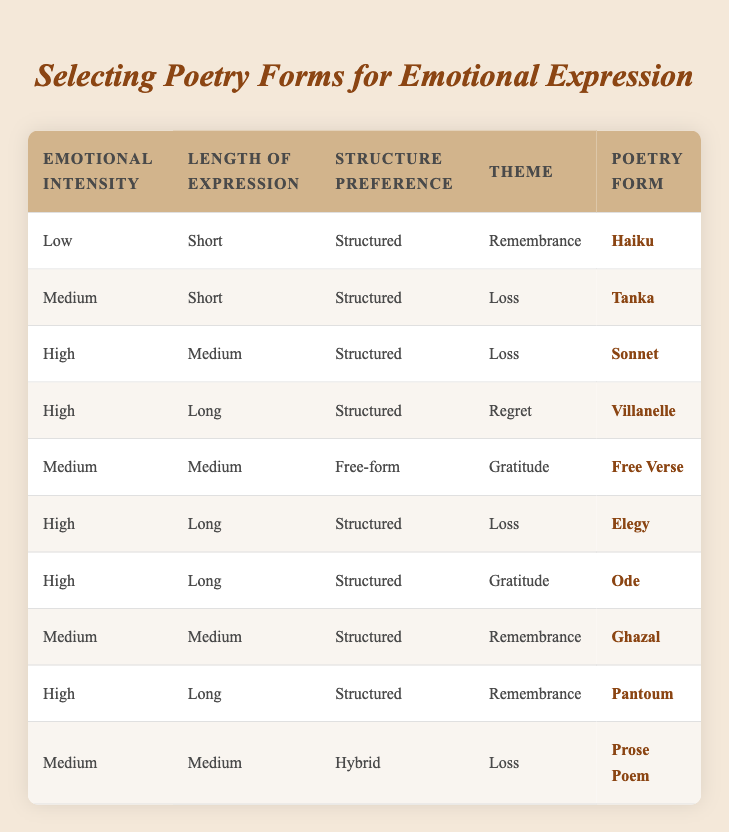What poetry form is recommended for low emotional intensity and remembrance? According to the table, when the emotional intensity is low, the length of expression is short, the structure preference is structured, and the theme is remembrance, the recommended poetry form is Haiku.
Answer: Haiku Which poetry forms are suggested for high emotional intensity? Looking through the table for high emotional intensity, I find the following poetry forms: Sonnet (High, Medium, Structured, Loss), Villanelle (High, Long, Structured, Regret), Elegy (High, Long, Structured, Loss), Ode (High, Long, Structured, Gratitude), Pantoum (High, Long, Structured, Remembrance).
Answer: Sonnet, Villanelle, Elegy, Ode, Pantoum Is there a structured poetry form suggested for medium emotional intensity and medium length with the theme of loss? Yes, the table indicates that for medium emotional intensity, medium length, structured preference, and theme of loss, the suggested poetry form is Prose Poem.
Answer: Yes What is the most recommended poetry form for high emotional intensity with the theme of gratitude? The table shows that when emotional intensity is high, length is long, structure is structured, and theme is gratitude, the recommended poetry form is Ode.
Answer: Ode How many poetry forms are suggested for medium emotional intensity? By reviewing the table, I find three poetry forms recommended for medium emotional intensity: Free Verse from the medium length and gratitude, Ghazal from medium length and remembrance, and Prose Poem from medium length and loss. That sums up to three forms.
Answer: Three 